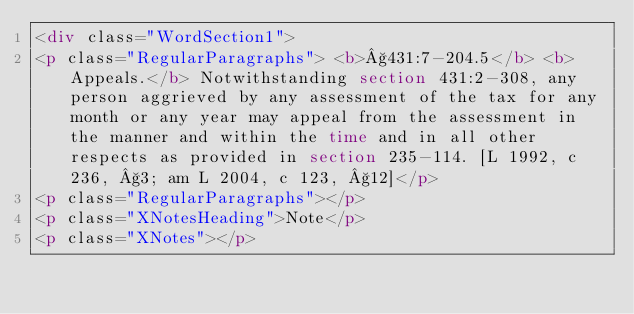Convert code to text. <code><loc_0><loc_0><loc_500><loc_500><_HTML_><div class="WordSection1">
<p class="RegularParagraphs"> <b>§431:7-204.5</b> <b>Appeals.</b> Notwithstanding section 431:2-308, any person aggrieved by any assessment of the tax for any month or any year may appeal from the assessment in the manner and within the time and in all other respects as provided in section 235-114. [L 1992, c 236, §3; am L 2004, c 123, §12]</p>
<p class="RegularParagraphs"></p>
<p class="XNotesHeading">Note</p>
<p class="XNotes"></p></code> 